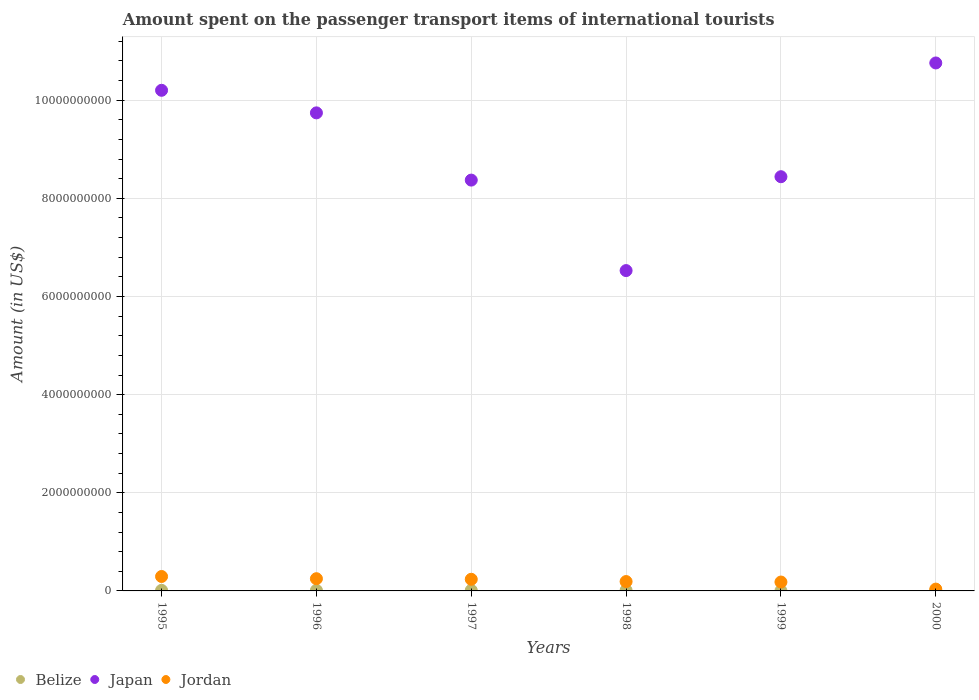Is the number of dotlines equal to the number of legend labels?
Your answer should be compact. Yes. What is the amount spent on the passenger transport items of international tourists in Japan in 1995?
Your response must be concise. 1.02e+1. Across all years, what is the maximum amount spent on the passenger transport items of international tourists in Jordan?
Give a very brief answer. 2.94e+08. Across all years, what is the minimum amount spent on the passenger transport items of international tourists in Belize?
Provide a short and direct response. 3.00e+06. In which year was the amount spent on the passenger transport items of international tourists in Japan maximum?
Provide a succinct answer. 2000. What is the total amount spent on the passenger transport items of international tourists in Jordan in the graph?
Provide a short and direct response. 1.19e+09. What is the difference between the amount spent on the passenger transport items of international tourists in Jordan in 1996 and that in 2000?
Offer a terse response. 2.12e+08. What is the difference between the amount spent on the passenger transport items of international tourists in Belize in 1998 and the amount spent on the passenger transport items of international tourists in Japan in 1996?
Your answer should be compact. -9.73e+09. What is the average amount spent on the passenger transport items of international tourists in Jordan per year?
Your answer should be very brief. 1.98e+08. In the year 1996, what is the difference between the amount spent on the passenger transport items of international tourists in Belize and amount spent on the passenger transport items of international tourists in Jordan?
Offer a very short reply. -2.37e+08. What is the ratio of the amount spent on the passenger transport items of international tourists in Japan in 1997 to that in 2000?
Your answer should be very brief. 0.78. Is the amount spent on the passenger transport items of international tourists in Jordan in 1998 less than that in 2000?
Your response must be concise. No. Is the difference between the amount spent on the passenger transport items of international tourists in Belize in 1996 and 1997 greater than the difference between the amount spent on the passenger transport items of international tourists in Jordan in 1996 and 1997?
Ensure brevity in your answer.  No. What is the difference between the highest and the lowest amount spent on the passenger transport items of international tourists in Belize?
Your answer should be compact. 9.00e+06. Is the amount spent on the passenger transport items of international tourists in Belize strictly greater than the amount spent on the passenger transport items of international tourists in Japan over the years?
Offer a very short reply. No. Is the amount spent on the passenger transport items of international tourists in Japan strictly less than the amount spent on the passenger transport items of international tourists in Jordan over the years?
Keep it short and to the point. No. What is the difference between two consecutive major ticks on the Y-axis?
Keep it short and to the point. 2.00e+09. Does the graph contain any zero values?
Offer a very short reply. No. Does the graph contain grids?
Give a very brief answer. Yes. What is the title of the graph?
Offer a very short reply. Amount spent on the passenger transport items of international tourists. Does "Gabon" appear as one of the legend labels in the graph?
Keep it short and to the point. No. What is the label or title of the X-axis?
Keep it short and to the point. Years. What is the label or title of the Y-axis?
Give a very brief answer. Amount (in US$). What is the Amount (in US$) in Japan in 1995?
Make the answer very short. 1.02e+1. What is the Amount (in US$) of Jordan in 1995?
Make the answer very short. 2.94e+08. What is the Amount (in US$) in Japan in 1996?
Your answer should be compact. 9.74e+09. What is the Amount (in US$) in Jordan in 1996?
Give a very brief answer. 2.49e+08. What is the Amount (in US$) in Japan in 1997?
Your response must be concise. 8.37e+09. What is the Amount (in US$) in Jordan in 1997?
Give a very brief answer. 2.37e+08. What is the Amount (in US$) of Japan in 1998?
Provide a succinct answer. 6.53e+09. What is the Amount (in US$) in Jordan in 1998?
Your answer should be compact. 1.91e+08. What is the Amount (in US$) of Japan in 1999?
Make the answer very short. 8.44e+09. What is the Amount (in US$) in Jordan in 1999?
Offer a terse response. 1.81e+08. What is the Amount (in US$) in Belize in 2000?
Make the answer very short. 4.00e+06. What is the Amount (in US$) in Japan in 2000?
Your response must be concise. 1.08e+1. What is the Amount (in US$) of Jordan in 2000?
Your answer should be compact. 3.70e+07. Across all years, what is the maximum Amount (in US$) of Belize?
Provide a succinct answer. 1.20e+07. Across all years, what is the maximum Amount (in US$) in Japan?
Offer a terse response. 1.08e+1. Across all years, what is the maximum Amount (in US$) in Jordan?
Give a very brief answer. 2.94e+08. Across all years, what is the minimum Amount (in US$) in Japan?
Keep it short and to the point. 6.53e+09. Across all years, what is the minimum Amount (in US$) of Jordan?
Provide a short and direct response. 3.70e+07. What is the total Amount (in US$) of Belize in the graph?
Give a very brief answer. 5.50e+07. What is the total Amount (in US$) in Japan in the graph?
Your answer should be very brief. 5.40e+1. What is the total Amount (in US$) in Jordan in the graph?
Give a very brief answer. 1.19e+09. What is the difference between the Amount (in US$) of Japan in 1995 and that in 1996?
Give a very brief answer. 4.60e+08. What is the difference between the Amount (in US$) in Jordan in 1995 and that in 1996?
Provide a succinct answer. 4.50e+07. What is the difference between the Amount (in US$) in Japan in 1995 and that in 1997?
Make the answer very short. 1.83e+09. What is the difference between the Amount (in US$) of Jordan in 1995 and that in 1997?
Offer a very short reply. 5.70e+07. What is the difference between the Amount (in US$) of Belize in 1995 and that in 1998?
Give a very brief answer. 0. What is the difference between the Amount (in US$) in Japan in 1995 and that in 1998?
Make the answer very short. 3.67e+09. What is the difference between the Amount (in US$) of Jordan in 1995 and that in 1998?
Offer a very short reply. 1.03e+08. What is the difference between the Amount (in US$) in Belize in 1995 and that in 1999?
Ensure brevity in your answer.  9.00e+06. What is the difference between the Amount (in US$) of Japan in 1995 and that in 1999?
Make the answer very short. 1.76e+09. What is the difference between the Amount (in US$) in Jordan in 1995 and that in 1999?
Keep it short and to the point. 1.13e+08. What is the difference between the Amount (in US$) in Belize in 1995 and that in 2000?
Your answer should be compact. 8.00e+06. What is the difference between the Amount (in US$) in Japan in 1995 and that in 2000?
Offer a terse response. -5.57e+08. What is the difference between the Amount (in US$) in Jordan in 1995 and that in 2000?
Make the answer very short. 2.57e+08. What is the difference between the Amount (in US$) in Belize in 1996 and that in 1997?
Your answer should be compact. 0. What is the difference between the Amount (in US$) in Japan in 1996 and that in 1997?
Ensure brevity in your answer.  1.37e+09. What is the difference between the Amount (in US$) in Jordan in 1996 and that in 1997?
Your response must be concise. 1.20e+07. What is the difference between the Amount (in US$) of Japan in 1996 and that in 1998?
Provide a succinct answer. 3.21e+09. What is the difference between the Amount (in US$) of Jordan in 1996 and that in 1998?
Keep it short and to the point. 5.80e+07. What is the difference between the Amount (in US$) of Belize in 1996 and that in 1999?
Ensure brevity in your answer.  9.00e+06. What is the difference between the Amount (in US$) of Japan in 1996 and that in 1999?
Your answer should be very brief. 1.30e+09. What is the difference between the Amount (in US$) in Jordan in 1996 and that in 1999?
Give a very brief answer. 6.80e+07. What is the difference between the Amount (in US$) of Japan in 1996 and that in 2000?
Give a very brief answer. -1.02e+09. What is the difference between the Amount (in US$) in Jordan in 1996 and that in 2000?
Offer a very short reply. 2.12e+08. What is the difference between the Amount (in US$) of Japan in 1997 and that in 1998?
Offer a very short reply. 1.84e+09. What is the difference between the Amount (in US$) in Jordan in 1997 and that in 1998?
Make the answer very short. 4.60e+07. What is the difference between the Amount (in US$) of Belize in 1997 and that in 1999?
Your response must be concise. 9.00e+06. What is the difference between the Amount (in US$) in Japan in 1997 and that in 1999?
Keep it short and to the point. -6.90e+07. What is the difference between the Amount (in US$) of Jordan in 1997 and that in 1999?
Make the answer very short. 5.60e+07. What is the difference between the Amount (in US$) in Belize in 1997 and that in 2000?
Ensure brevity in your answer.  8.00e+06. What is the difference between the Amount (in US$) in Japan in 1997 and that in 2000?
Your answer should be very brief. -2.39e+09. What is the difference between the Amount (in US$) in Belize in 1998 and that in 1999?
Offer a very short reply. 9.00e+06. What is the difference between the Amount (in US$) of Japan in 1998 and that in 1999?
Your answer should be very brief. -1.91e+09. What is the difference between the Amount (in US$) in Jordan in 1998 and that in 1999?
Give a very brief answer. 1.00e+07. What is the difference between the Amount (in US$) of Japan in 1998 and that in 2000?
Ensure brevity in your answer.  -4.23e+09. What is the difference between the Amount (in US$) in Jordan in 1998 and that in 2000?
Provide a short and direct response. 1.54e+08. What is the difference between the Amount (in US$) in Japan in 1999 and that in 2000?
Ensure brevity in your answer.  -2.32e+09. What is the difference between the Amount (in US$) in Jordan in 1999 and that in 2000?
Ensure brevity in your answer.  1.44e+08. What is the difference between the Amount (in US$) of Belize in 1995 and the Amount (in US$) of Japan in 1996?
Offer a terse response. -9.73e+09. What is the difference between the Amount (in US$) of Belize in 1995 and the Amount (in US$) of Jordan in 1996?
Give a very brief answer. -2.37e+08. What is the difference between the Amount (in US$) of Japan in 1995 and the Amount (in US$) of Jordan in 1996?
Make the answer very short. 9.95e+09. What is the difference between the Amount (in US$) of Belize in 1995 and the Amount (in US$) of Japan in 1997?
Provide a short and direct response. -8.36e+09. What is the difference between the Amount (in US$) of Belize in 1995 and the Amount (in US$) of Jordan in 1997?
Keep it short and to the point. -2.25e+08. What is the difference between the Amount (in US$) in Japan in 1995 and the Amount (in US$) in Jordan in 1997?
Ensure brevity in your answer.  9.96e+09. What is the difference between the Amount (in US$) in Belize in 1995 and the Amount (in US$) in Japan in 1998?
Give a very brief answer. -6.52e+09. What is the difference between the Amount (in US$) of Belize in 1995 and the Amount (in US$) of Jordan in 1998?
Offer a terse response. -1.79e+08. What is the difference between the Amount (in US$) of Japan in 1995 and the Amount (in US$) of Jordan in 1998?
Offer a terse response. 1.00e+1. What is the difference between the Amount (in US$) of Belize in 1995 and the Amount (in US$) of Japan in 1999?
Your response must be concise. -8.43e+09. What is the difference between the Amount (in US$) in Belize in 1995 and the Amount (in US$) in Jordan in 1999?
Make the answer very short. -1.69e+08. What is the difference between the Amount (in US$) of Japan in 1995 and the Amount (in US$) of Jordan in 1999?
Keep it short and to the point. 1.00e+1. What is the difference between the Amount (in US$) in Belize in 1995 and the Amount (in US$) in Japan in 2000?
Your answer should be compact. -1.07e+1. What is the difference between the Amount (in US$) in Belize in 1995 and the Amount (in US$) in Jordan in 2000?
Your response must be concise. -2.50e+07. What is the difference between the Amount (in US$) in Japan in 1995 and the Amount (in US$) in Jordan in 2000?
Offer a terse response. 1.02e+1. What is the difference between the Amount (in US$) of Belize in 1996 and the Amount (in US$) of Japan in 1997?
Keep it short and to the point. -8.36e+09. What is the difference between the Amount (in US$) of Belize in 1996 and the Amount (in US$) of Jordan in 1997?
Provide a short and direct response. -2.25e+08. What is the difference between the Amount (in US$) in Japan in 1996 and the Amount (in US$) in Jordan in 1997?
Make the answer very short. 9.50e+09. What is the difference between the Amount (in US$) in Belize in 1996 and the Amount (in US$) in Japan in 1998?
Your answer should be very brief. -6.52e+09. What is the difference between the Amount (in US$) of Belize in 1996 and the Amount (in US$) of Jordan in 1998?
Provide a succinct answer. -1.79e+08. What is the difference between the Amount (in US$) of Japan in 1996 and the Amount (in US$) of Jordan in 1998?
Your answer should be compact. 9.55e+09. What is the difference between the Amount (in US$) in Belize in 1996 and the Amount (in US$) in Japan in 1999?
Keep it short and to the point. -8.43e+09. What is the difference between the Amount (in US$) of Belize in 1996 and the Amount (in US$) of Jordan in 1999?
Make the answer very short. -1.69e+08. What is the difference between the Amount (in US$) in Japan in 1996 and the Amount (in US$) in Jordan in 1999?
Offer a very short reply. 9.56e+09. What is the difference between the Amount (in US$) in Belize in 1996 and the Amount (in US$) in Japan in 2000?
Offer a terse response. -1.07e+1. What is the difference between the Amount (in US$) in Belize in 1996 and the Amount (in US$) in Jordan in 2000?
Your answer should be compact. -2.50e+07. What is the difference between the Amount (in US$) of Japan in 1996 and the Amount (in US$) of Jordan in 2000?
Your answer should be very brief. 9.70e+09. What is the difference between the Amount (in US$) of Belize in 1997 and the Amount (in US$) of Japan in 1998?
Your answer should be very brief. -6.52e+09. What is the difference between the Amount (in US$) in Belize in 1997 and the Amount (in US$) in Jordan in 1998?
Make the answer very short. -1.79e+08. What is the difference between the Amount (in US$) in Japan in 1997 and the Amount (in US$) in Jordan in 1998?
Ensure brevity in your answer.  8.18e+09. What is the difference between the Amount (in US$) of Belize in 1997 and the Amount (in US$) of Japan in 1999?
Ensure brevity in your answer.  -8.43e+09. What is the difference between the Amount (in US$) of Belize in 1997 and the Amount (in US$) of Jordan in 1999?
Make the answer very short. -1.69e+08. What is the difference between the Amount (in US$) of Japan in 1997 and the Amount (in US$) of Jordan in 1999?
Your answer should be compact. 8.19e+09. What is the difference between the Amount (in US$) of Belize in 1997 and the Amount (in US$) of Japan in 2000?
Offer a very short reply. -1.07e+1. What is the difference between the Amount (in US$) of Belize in 1997 and the Amount (in US$) of Jordan in 2000?
Your answer should be very brief. -2.50e+07. What is the difference between the Amount (in US$) of Japan in 1997 and the Amount (in US$) of Jordan in 2000?
Offer a very short reply. 8.34e+09. What is the difference between the Amount (in US$) in Belize in 1998 and the Amount (in US$) in Japan in 1999?
Give a very brief answer. -8.43e+09. What is the difference between the Amount (in US$) in Belize in 1998 and the Amount (in US$) in Jordan in 1999?
Offer a very short reply. -1.69e+08. What is the difference between the Amount (in US$) in Japan in 1998 and the Amount (in US$) in Jordan in 1999?
Offer a very short reply. 6.35e+09. What is the difference between the Amount (in US$) of Belize in 1998 and the Amount (in US$) of Japan in 2000?
Provide a short and direct response. -1.07e+1. What is the difference between the Amount (in US$) in Belize in 1998 and the Amount (in US$) in Jordan in 2000?
Offer a very short reply. -2.50e+07. What is the difference between the Amount (in US$) in Japan in 1998 and the Amount (in US$) in Jordan in 2000?
Provide a succinct answer. 6.49e+09. What is the difference between the Amount (in US$) in Belize in 1999 and the Amount (in US$) in Japan in 2000?
Your response must be concise. -1.08e+1. What is the difference between the Amount (in US$) in Belize in 1999 and the Amount (in US$) in Jordan in 2000?
Offer a terse response. -3.40e+07. What is the difference between the Amount (in US$) in Japan in 1999 and the Amount (in US$) in Jordan in 2000?
Offer a very short reply. 8.40e+09. What is the average Amount (in US$) of Belize per year?
Your answer should be compact. 9.17e+06. What is the average Amount (in US$) of Japan per year?
Give a very brief answer. 9.01e+09. What is the average Amount (in US$) of Jordan per year?
Give a very brief answer. 1.98e+08. In the year 1995, what is the difference between the Amount (in US$) in Belize and Amount (in US$) in Japan?
Keep it short and to the point. -1.02e+1. In the year 1995, what is the difference between the Amount (in US$) of Belize and Amount (in US$) of Jordan?
Offer a terse response. -2.82e+08. In the year 1995, what is the difference between the Amount (in US$) in Japan and Amount (in US$) in Jordan?
Ensure brevity in your answer.  9.91e+09. In the year 1996, what is the difference between the Amount (in US$) in Belize and Amount (in US$) in Japan?
Make the answer very short. -9.73e+09. In the year 1996, what is the difference between the Amount (in US$) of Belize and Amount (in US$) of Jordan?
Your response must be concise. -2.37e+08. In the year 1996, what is the difference between the Amount (in US$) of Japan and Amount (in US$) of Jordan?
Provide a succinct answer. 9.49e+09. In the year 1997, what is the difference between the Amount (in US$) in Belize and Amount (in US$) in Japan?
Your response must be concise. -8.36e+09. In the year 1997, what is the difference between the Amount (in US$) in Belize and Amount (in US$) in Jordan?
Give a very brief answer. -2.25e+08. In the year 1997, what is the difference between the Amount (in US$) in Japan and Amount (in US$) in Jordan?
Ensure brevity in your answer.  8.14e+09. In the year 1998, what is the difference between the Amount (in US$) in Belize and Amount (in US$) in Japan?
Provide a succinct answer. -6.52e+09. In the year 1998, what is the difference between the Amount (in US$) in Belize and Amount (in US$) in Jordan?
Offer a very short reply. -1.79e+08. In the year 1998, what is the difference between the Amount (in US$) in Japan and Amount (in US$) in Jordan?
Offer a terse response. 6.34e+09. In the year 1999, what is the difference between the Amount (in US$) in Belize and Amount (in US$) in Japan?
Offer a terse response. -8.44e+09. In the year 1999, what is the difference between the Amount (in US$) in Belize and Amount (in US$) in Jordan?
Provide a short and direct response. -1.78e+08. In the year 1999, what is the difference between the Amount (in US$) of Japan and Amount (in US$) of Jordan?
Your answer should be very brief. 8.26e+09. In the year 2000, what is the difference between the Amount (in US$) in Belize and Amount (in US$) in Japan?
Your response must be concise. -1.08e+1. In the year 2000, what is the difference between the Amount (in US$) of Belize and Amount (in US$) of Jordan?
Ensure brevity in your answer.  -3.30e+07. In the year 2000, what is the difference between the Amount (in US$) of Japan and Amount (in US$) of Jordan?
Make the answer very short. 1.07e+1. What is the ratio of the Amount (in US$) of Belize in 1995 to that in 1996?
Your answer should be compact. 1. What is the ratio of the Amount (in US$) in Japan in 1995 to that in 1996?
Provide a succinct answer. 1.05. What is the ratio of the Amount (in US$) in Jordan in 1995 to that in 1996?
Offer a very short reply. 1.18. What is the ratio of the Amount (in US$) of Belize in 1995 to that in 1997?
Provide a short and direct response. 1. What is the ratio of the Amount (in US$) in Japan in 1995 to that in 1997?
Make the answer very short. 1.22. What is the ratio of the Amount (in US$) in Jordan in 1995 to that in 1997?
Give a very brief answer. 1.24. What is the ratio of the Amount (in US$) in Japan in 1995 to that in 1998?
Give a very brief answer. 1.56. What is the ratio of the Amount (in US$) of Jordan in 1995 to that in 1998?
Provide a succinct answer. 1.54. What is the ratio of the Amount (in US$) of Belize in 1995 to that in 1999?
Keep it short and to the point. 4. What is the ratio of the Amount (in US$) in Japan in 1995 to that in 1999?
Offer a terse response. 1.21. What is the ratio of the Amount (in US$) of Jordan in 1995 to that in 1999?
Provide a succinct answer. 1.62. What is the ratio of the Amount (in US$) of Belize in 1995 to that in 2000?
Offer a very short reply. 3. What is the ratio of the Amount (in US$) of Japan in 1995 to that in 2000?
Make the answer very short. 0.95. What is the ratio of the Amount (in US$) of Jordan in 1995 to that in 2000?
Your answer should be compact. 7.95. What is the ratio of the Amount (in US$) of Japan in 1996 to that in 1997?
Your response must be concise. 1.16. What is the ratio of the Amount (in US$) of Jordan in 1996 to that in 1997?
Ensure brevity in your answer.  1.05. What is the ratio of the Amount (in US$) in Japan in 1996 to that in 1998?
Provide a short and direct response. 1.49. What is the ratio of the Amount (in US$) of Jordan in 1996 to that in 1998?
Make the answer very short. 1.3. What is the ratio of the Amount (in US$) in Japan in 1996 to that in 1999?
Provide a succinct answer. 1.15. What is the ratio of the Amount (in US$) of Jordan in 1996 to that in 1999?
Provide a short and direct response. 1.38. What is the ratio of the Amount (in US$) in Belize in 1996 to that in 2000?
Make the answer very short. 3. What is the ratio of the Amount (in US$) in Japan in 1996 to that in 2000?
Your answer should be compact. 0.91. What is the ratio of the Amount (in US$) of Jordan in 1996 to that in 2000?
Your response must be concise. 6.73. What is the ratio of the Amount (in US$) in Japan in 1997 to that in 1998?
Your answer should be very brief. 1.28. What is the ratio of the Amount (in US$) of Jordan in 1997 to that in 1998?
Your answer should be very brief. 1.24. What is the ratio of the Amount (in US$) in Japan in 1997 to that in 1999?
Provide a short and direct response. 0.99. What is the ratio of the Amount (in US$) of Jordan in 1997 to that in 1999?
Your response must be concise. 1.31. What is the ratio of the Amount (in US$) of Belize in 1997 to that in 2000?
Ensure brevity in your answer.  3. What is the ratio of the Amount (in US$) in Japan in 1997 to that in 2000?
Provide a succinct answer. 0.78. What is the ratio of the Amount (in US$) of Jordan in 1997 to that in 2000?
Make the answer very short. 6.41. What is the ratio of the Amount (in US$) of Belize in 1998 to that in 1999?
Your answer should be compact. 4. What is the ratio of the Amount (in US$) of Japan in 1998 to that in 1999?
Keep it short and to the point. 0.77. What is the ratio of the Amount (in US$) in Jordan in 1998 to that in 1999?
Offer a very short reply. 1.06. What is the ratio of the Amount (in US$) of Belize in 1998 to that in 2000?
Your answer should be compact. 3. What is the ratio of the Amount (in US$) in Japan in 1998 to that in 2000?
Keep it short and to the point. 0.61. What is the ratio of the Amount (in US$) of Jordan in 1998 to that in 2000?
Offer a very short reply. 5.16. What is the ratio of the Amount (in US$) in Japan in 1999 to that in 2000?
Make the answer very short. 0.78. What is the ratio of the Amount (in US$) in Jordan in 1999 to that in 2000?
Give a very brief answer. 4.89. What is the difference between the highest and the second highest Amount (in US$) in Belize?
Ensure brevity in your answer.  0. What is the difference between the highest and the second highest Amount (in US$) of Japan?
Give a very brief answer. 5.57e+08. What is the difference between the highest and the second highest Amount (in US$) of Jordan?
Keep it short and to the point. 4.50e+07. What is the difference between the highest and the lowest Amount (in US$) of Belize?
Provide a succinct answer. 9.00e+06. What is the difference between the highest and the lowest Amount (in US$) of Japan?
Keep it short and to the point. 4.23e+09. What is the difference between the highest and the lowest Amount (in US$) of Jordan?
Offer a terse response. 2.57e+08. 